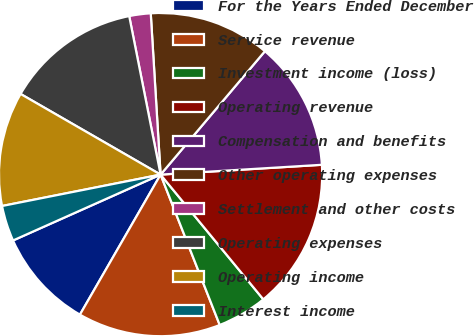Convert chart to OTSL. <chart><loc_0><loc_0><loc_500><loc_500><pie_chart><fcel>For the Years Ended December<fcel>Service revenue<fcel>Investment income (loss)<fcel>Operating revenue<fcel>Compensation and benefits<fcel>Other operating expenses<fcel>Settlement and other costs<fcel>Operating expenses<fcel>Operating income<fcel>Interest income<nl><fcel>10.0%<fcel>14.28%<fcel>5.0%<fcel>15.0%<fcel>12.86%<fcel>12.14%<fcel>2.14%<fcel>13.57%<fcel>11.43%<fcel>3.57%<nl></chart> 